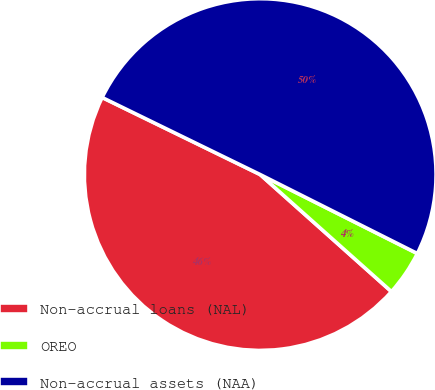Convert chart to OTSL. <chart><loc_0><loc_0><loc_500><loc_500><pie_chart><fcel>Non-accrual loans (NAL)<fcel>OREO<fcel>Non-accrual assets (NAA)<nl><fcel>45.63%<fcel>4.18%<fcel>50.19%<nl></chart> 